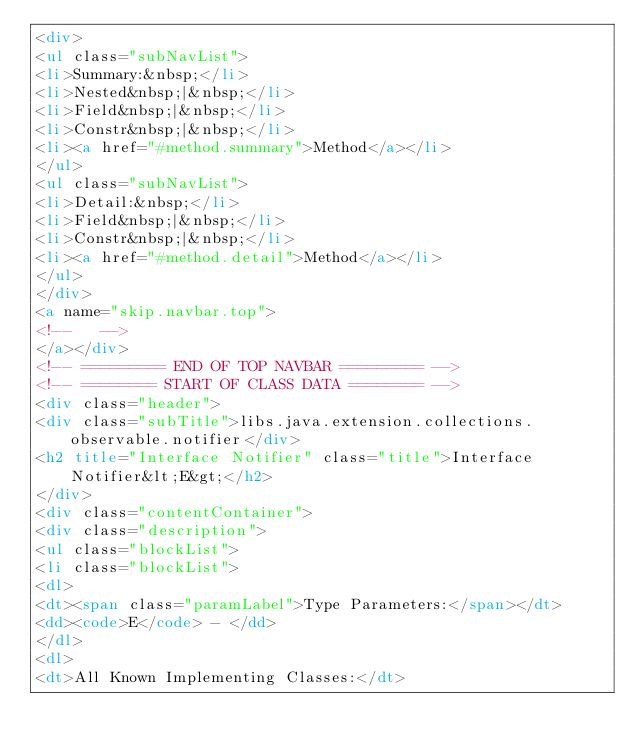Convert code to text. <code><loc_0><loc_0><loc_500><loc_500><_HTML_><div>
<ul class="subNavList">
<li>Summary:&nbsp;</li>
<li>Nested&nbsp;|&nbsp;</li>
<li>Field&nbsp;|&nbsp;</li>
<li>Constr&nbsp;|&nbsp;</li>
<li><a href="#method.summary">Method</a></li>
</ul>
<ul class="subNavList">
<li>Detail:&nbsp;</li>
<li>Field&nbsp;|&nbsp;</li>
<li>Constr&nbsp;|&nbsp;</li>
<li><a href="#method.detail">Method</a></li>
</ul>
</div>
<a name="skip.navbar.top">
<!--   -->
</a></div>
<!-- ========= END OF TOP NAVBAR ========= -->
<!-- ======== START OF CLASS DATA ======== -->
<div class="header">
<div class="subTitle">libs.java.extension.collections.observable.notifier</div>
<h2 title="Interface Notifier" class="title">Interface Notifier&lt;E&gt;</h2>
</div>
<div class="contentContainer">
<div class="description">
<ul class="blockList">
<li class="blockList">
<dl>
<dt><span class="paramLabel">Type Parameters:</span></dt>
<dd><code>E</code> - </dd>
</dl>
<dl>
<dt>All Known Implementing Classes:</dt></code> 